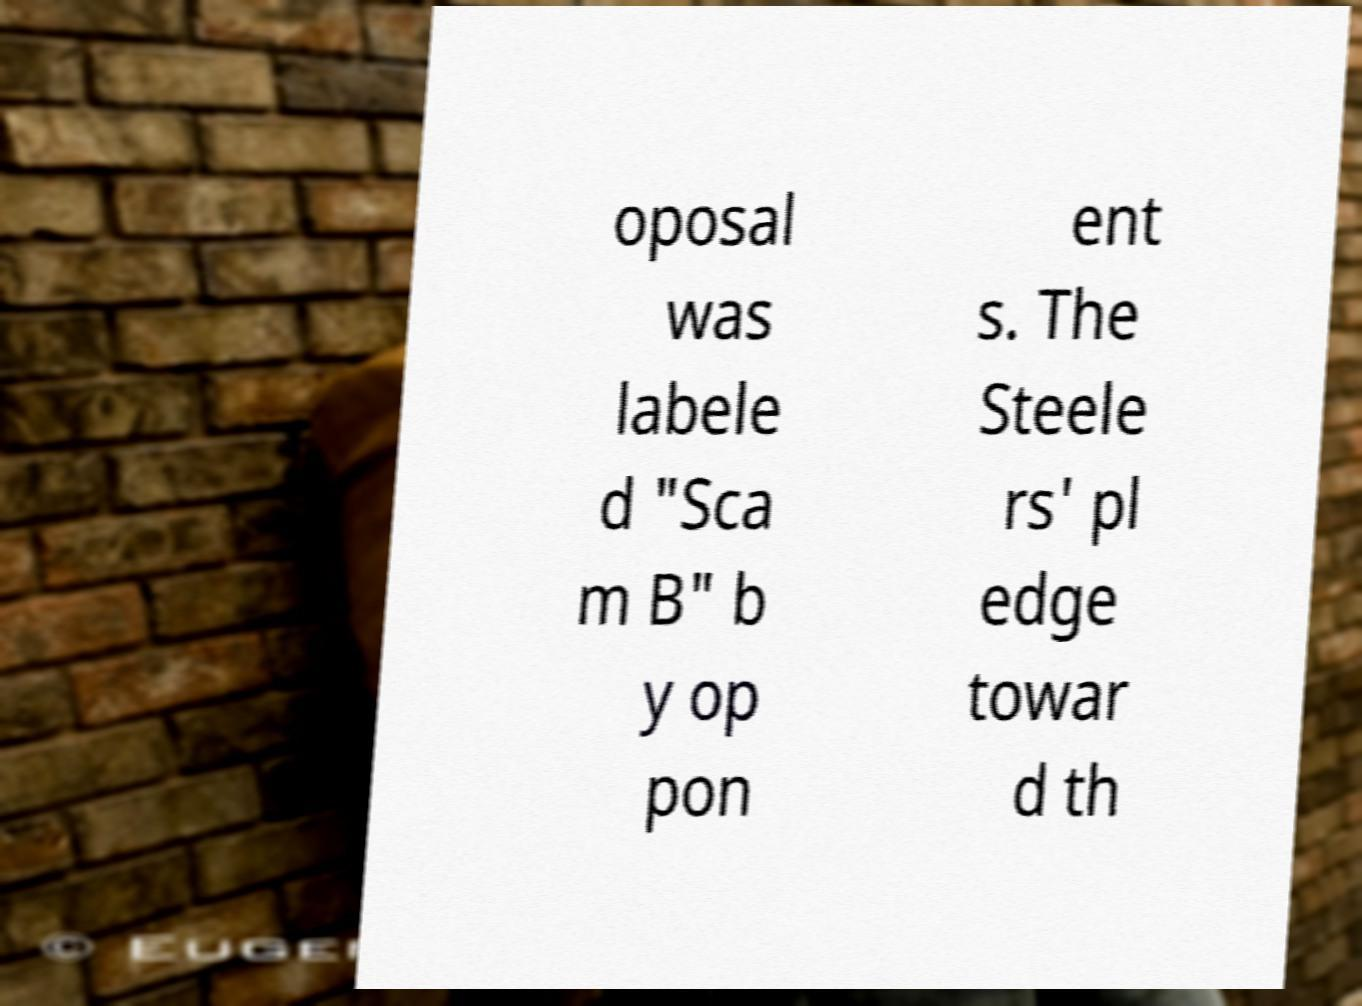Please identify and transcribe the text found in this image. oposal was labele d "Sca m B" b y op pon ent s. The Steele rs' pl edge towar d th 